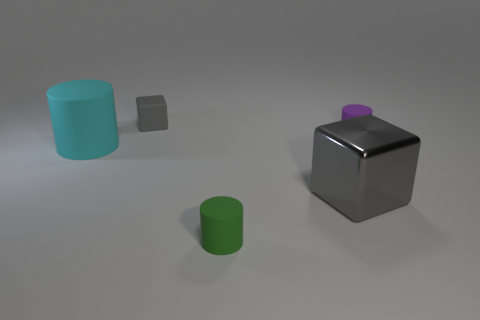Add 1 large gray cubes. How many objects exist? 6 Subtract all blocks. How many objects are left? 3 Subtract all large gray metal things. Subtract all cyan cylinders. How many objects are left? 3 Add 1 large objects. How many large objects are left? 3 Add 1 green cylinders. How many green cylinders exist? 2 Subtract 0 green spheres. How many objects are left? 5 